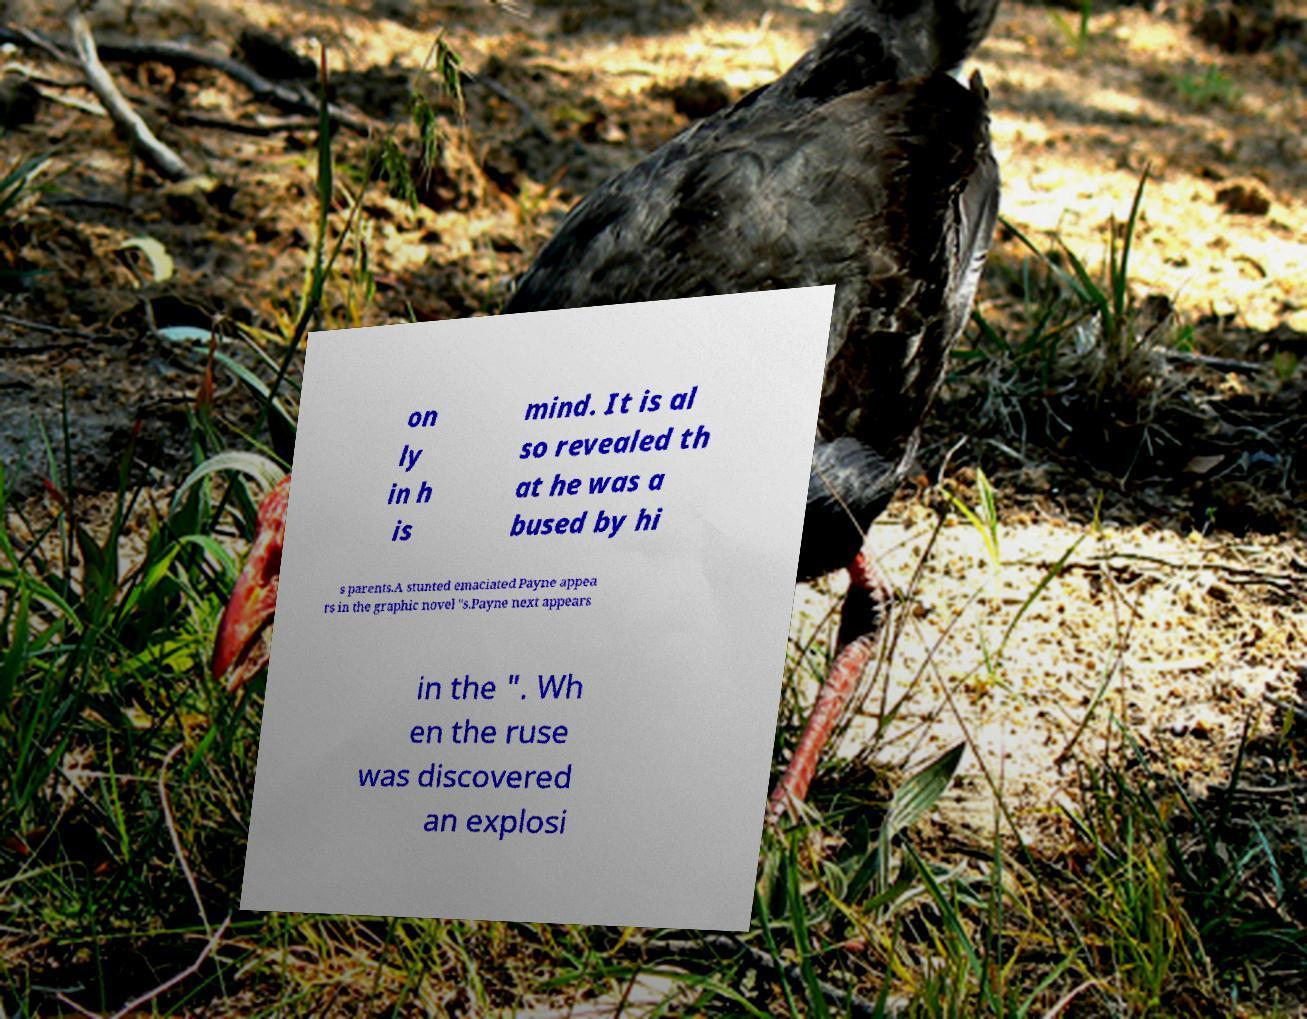Can you read and provide the text displayed in the image?This photo seems to have some interesting text. Can you extract and type it out for me? on ly in h is mind. It is al so revealed th at he was a bused by hi s parents.A stunted emaciated Payne appea rs in the graphic novel "s.Payne next appears in the ". Wh en the ruse was discovered an explosi 